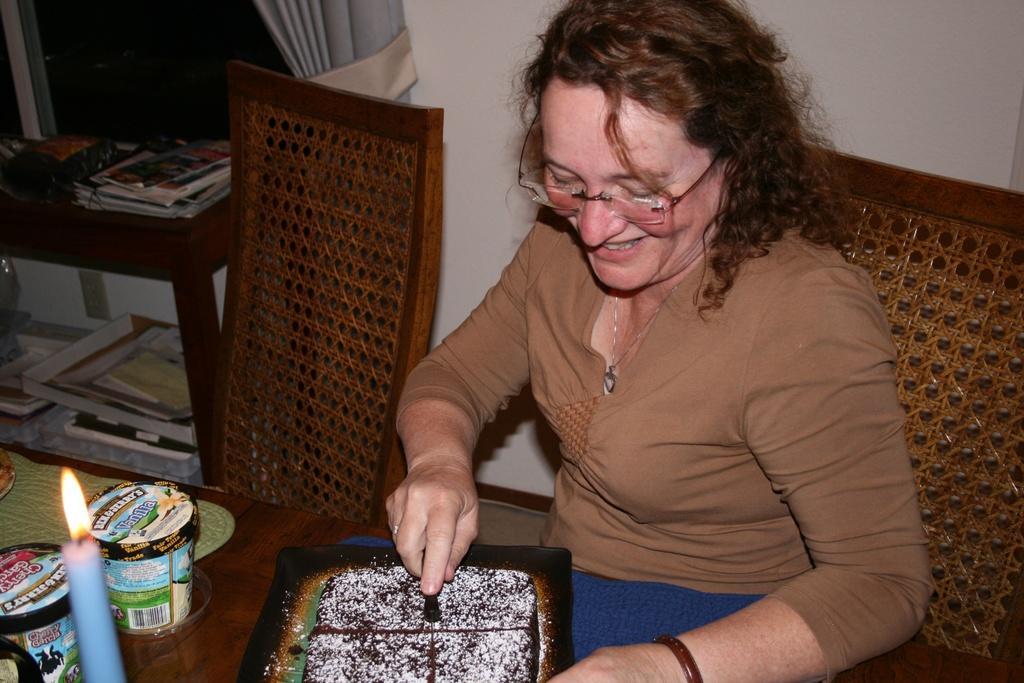Please provide a concise description of this image. In this image I can see a woman is sitting on a chair. I can also see a smile on her face and she is wearing a specs. Here on this table I can see a cake, a candle and few cups. 